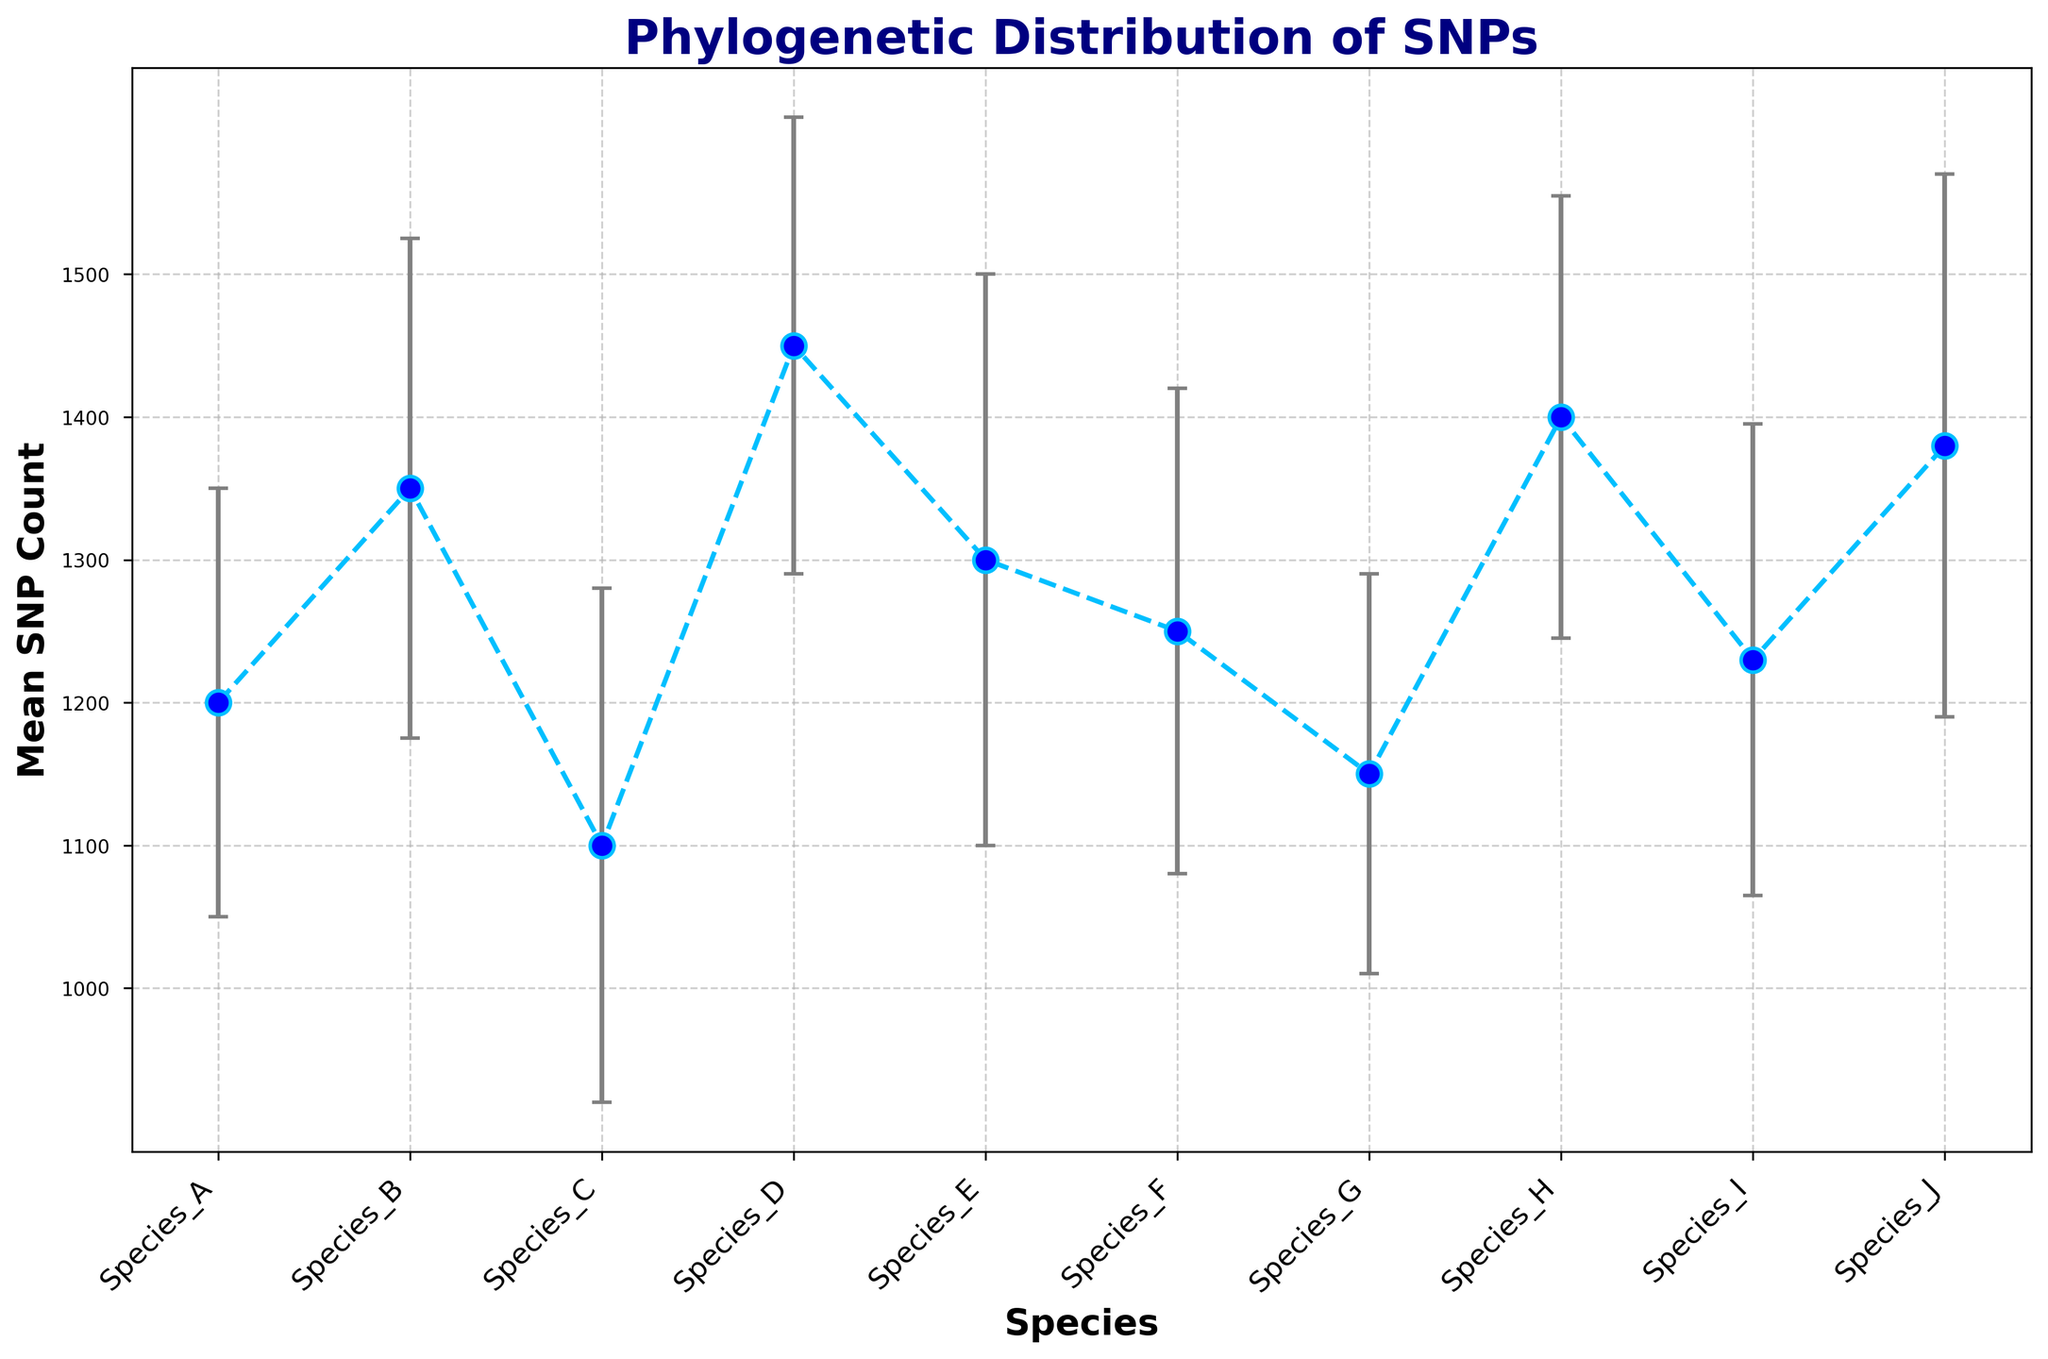What's the mean SNP count for Species C? The mean SNP count for each species is listed on the y-axis. Locate the mean SNP count for Species C on the y-axis.
Answer: 1100 Which species has the highest average SNP count? The species with the highest average SNP count will have the highest mean SNP value on the y-axis.
Answer: Species D Which species has the lowest average SNP count? The species with the lowest average SNP count will have the lowest mean SNP value on the y-axis.
Answer: Species C What is the range of mean SNP counts in this dataset? Identify the highest and lowest mean SNP counts from the y-axis values. The range is the difference between these two values. The highest is 1450 (Species D) and the lowest is 1100 (Species C). The range is 1450 - 1100.
Answer: 350 How does the SNP count of Species J compare to Species B? Compare the mean SNP counts of Species J and Species B by locating their respective points on the plot and noting their y-axis values.
Answer: Species J has a lower mean SNP count than Species B Which species has the smallest error margin in SNP count? The error margin is represented by the error bars. The species with the smallest error bar has the smallest margin.
Answer: Species G Are there any species with overlapping error bars? Check if the error bars of any species overlap visually. This would indicate that the variation in their SNP counts is statistically within the same range.
Answer: Yes By how much does the mean SNP count of Species D exceed that of Species E? Subtract the mean SNP count of Species E from that of Species D. Mean SNP count of Species D is 1450 and for Species E is 1300. So, 1450 - 1300.
Answer: 150 What is the average standard deviation across all species? Add up all the standard deviations given in the dataset and divide by the number of species (10). (150 + 175 + 180 + 160 + 200 + 170 + 140 + 155 + 165 + 190) / 10 = 1685 / 10.
Answer: 168.5 